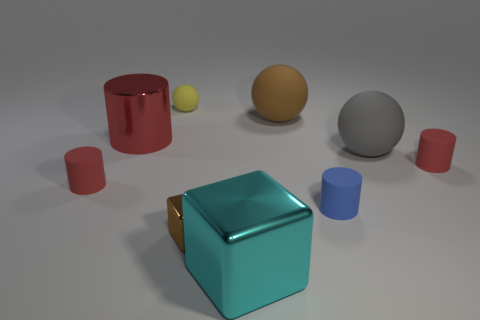Subtract all red cylinders. How many were subtracted if there are2red cylinders left? 1 Subtract all cyan blocks. How many red cylinders are left? 3 Subtract all tiny blue cylinders. How many cylinders are left? 3 Subtract all blue cylinders. How many cylinders are left? 3 Subtract 1 cylinders. How many cylinders are left? 3 Subtract all cyan cylinders. Subtract all yellow balls. How many cylinders are left? 4 Subtract all spheres. How many objects are left? 6 Subtract 0 cyan cylinders. How many objects are left? 9 Subtract all large yellow metal cubes. Subtract all tiny cylinders. How many objects are left? 6 Add 2 cyan objects. How many cyan objects are left? 3 